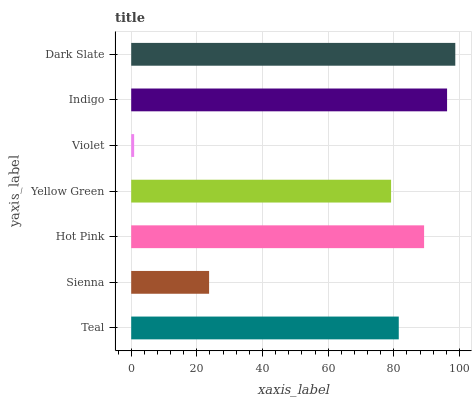Is Violet the minimum?
Answer yes or no. Yes. Is Dark Slate the maximum?
Answer yes or no. Yes. Is Sienna the minimum?
Answer yes or no. No. Is Sienna the maximum?
Answer yes or no. No. Is Teal greater than Sienna?
Answer yes or no. Yes. Is Sienna less than Teal?
Answer yes or no. Yes. Is Sienna greater than Teal?
Answer yes or no. No. Is Teal less than Sienna?
Answer yes or no. No. Is Teal the high median?
Answer yes or no. Yes. Is Teal the low median?
Answer yes or no. Yes. Is Dark Slate the high median?
Answer yes or no. No. Is Yellow Green the low median?
Answer yes or no. No. 